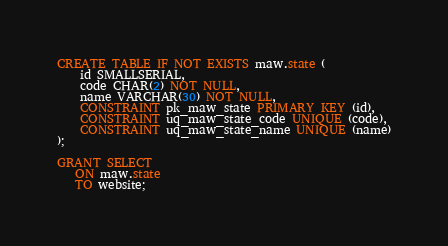<code> <loc_0><loc_0><loc_500><loc_500><_SQL_>CREATE TABLE IF NOT EXISTS maw.state (
    id SMALLSERIAL,
    code CHAR(2) NOT NULL,
    name VARCHAR(30) NOT NULL,
    CONSTRAINT pk_maw_state PRIMARY KEY (id),
    CONSTRAINT uq_maw_state_code UNIQUE (code),
    CONSTRAINT uq_maw_state_name UNIQUE (name)
);

GRANT SELECT
   ON maw.state
   TO website;
</code> 